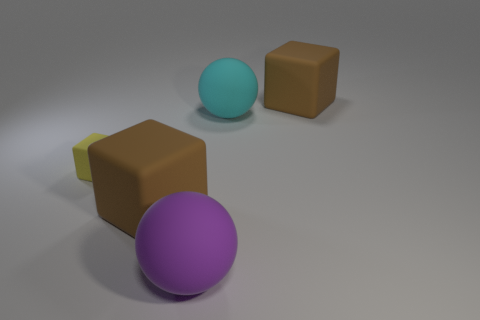The big thing behind the cyan sphere is what color?
Offer a terse response. Brown. How many yellow rubber objects are the same size as the purple sphere?
Provide a short and direct response. 0. There is a brown object that is behind the yellow matte thing; is its shape the same as the big brown object that is left of the large purple rubber ball?
Your response must be concise. Yes. There is a big brown object to the left of the matte cube behind the rubber sphere that is on the right side of the purple ball; what is its material?
Make the answer very short. Rubber. There is a purple thing that is the same size as the cyan object; what shape is it?
Your answer should be very brief. Sphere. What is the size of the purple object?
Ensure brevity in your answer.  Large. There is a brown object to the right of the brown cube that is in front of the small yellow thing; what number of big objects are to the left of it?
Offer a very short reply. 3. The big brown matte thing that is to the right of the cyan matte thing has what shape?
Give a very brief answer. Cube. What number of other things are there of the same material as the yellow object
Offer a terse response. 4. Is the number of cyan rubber objects that are left of the large purple rubber thing less than the number of big brown cubes right of the big cyan rubber ball?
Your answer should be very brief. Yes. 